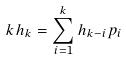<formula> <loc_0><loc_0><loc_500><loc_500>k h _ { k } = \sum _ { i = 1 } ^ { k } h _ { k - i } p _ { i }</formula> 